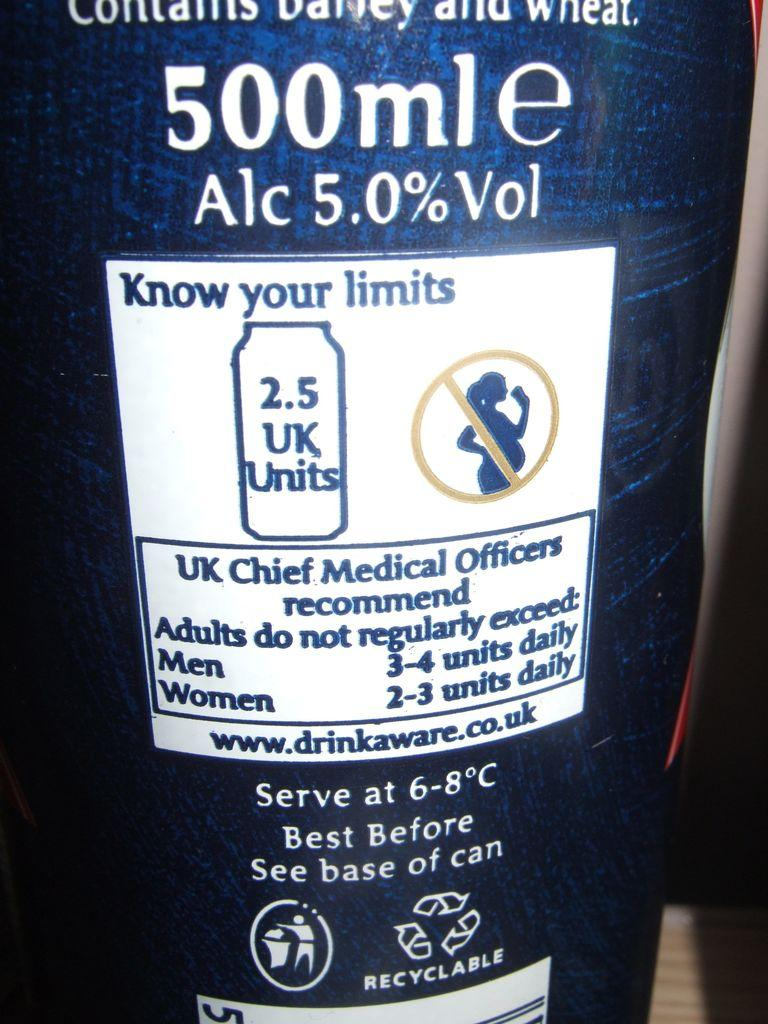Provide a one-sentence caption for the provided image. Back label of beer bottle with advisory to know your limits when drinking alcohol. 